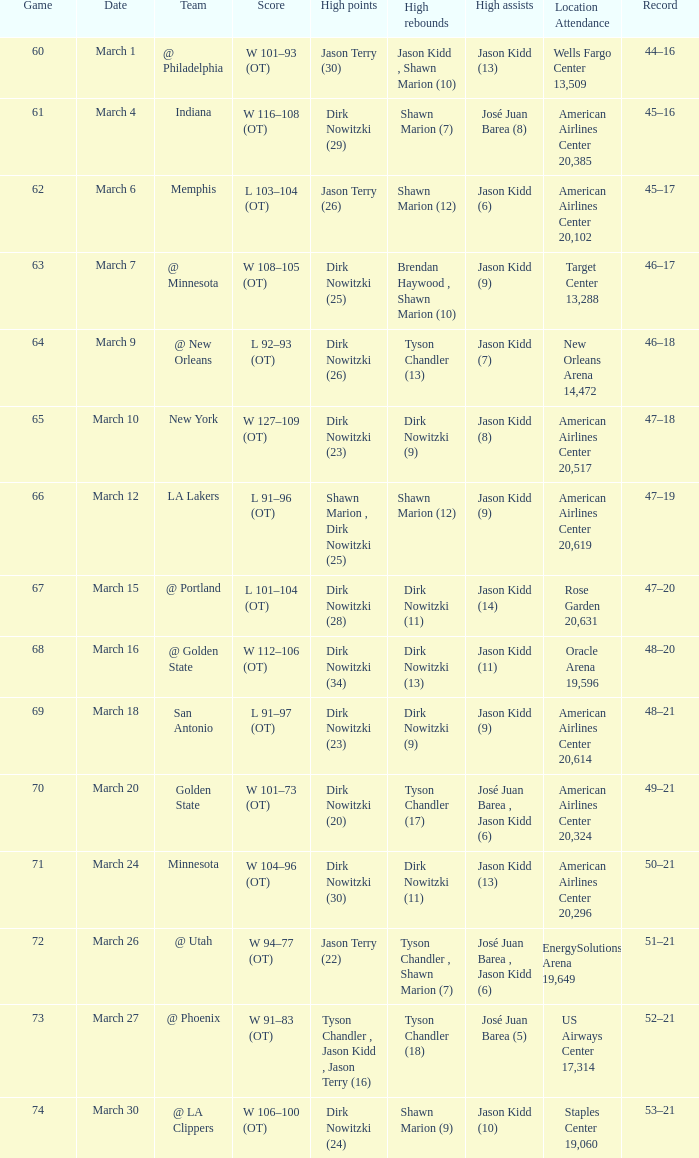List the peak moments for march 3 Dirk Nowitzki (24). 